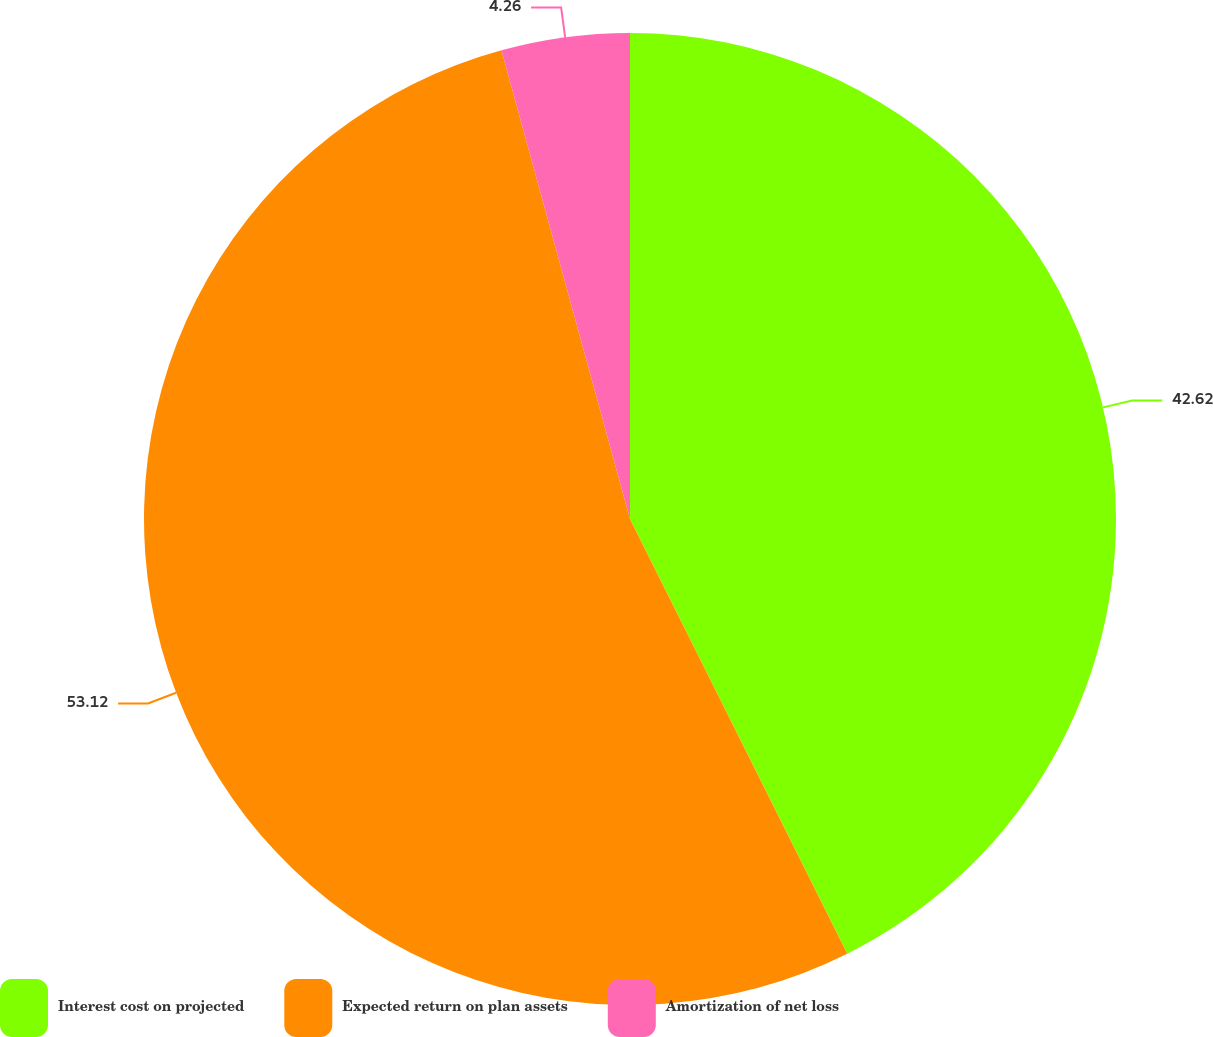<chart> <loc_0><loc_0><loc_500><loc_500><pie_chart><fcel>Interest cost on projected<fcel>Expected return on plan assets<fcel>Amortization of net loss<nl><fcel>42.62%<fcel>53.11%<fcel>4.26%<nl></chart> 